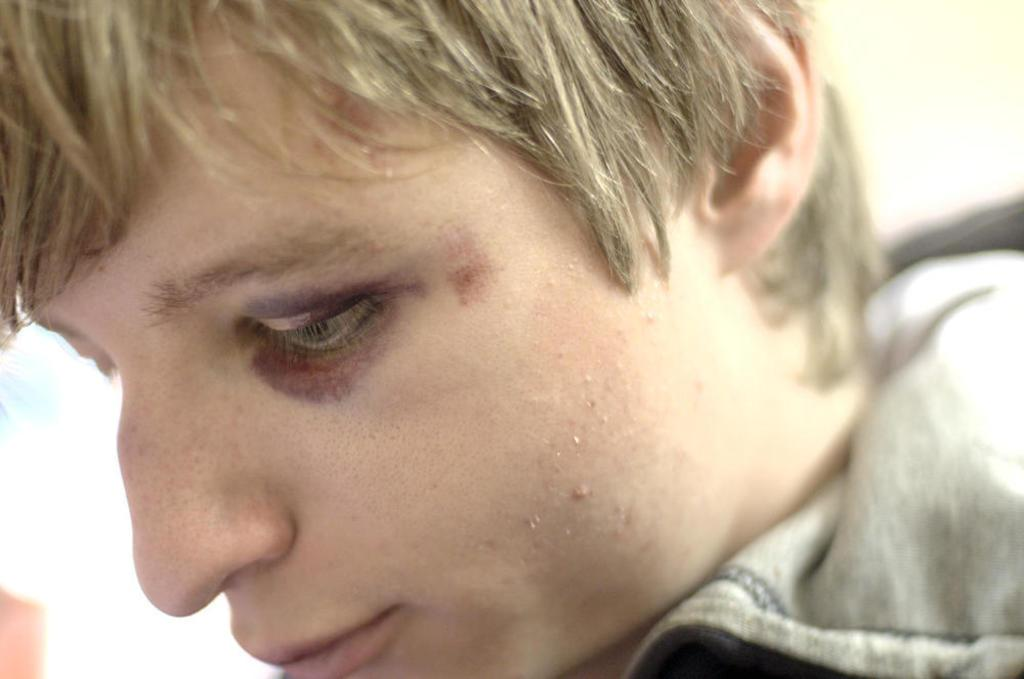What is the main subject of the image? There is a man in the image. How many times does the man kiss the pan in the image? There is no pan or kissing action present in the image; it only features a man. 